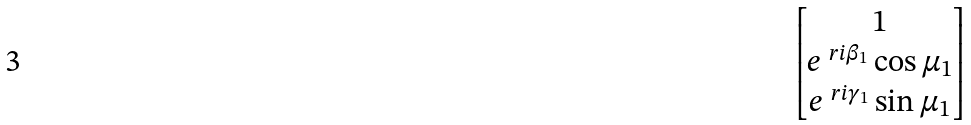Convert formula to latex. <formula><loc_0><loc_0><loc_500><loc_500>\begin{bmatrix} 1 \\ e ^ { \ r i \beta _ { 1 } } \cos \mu _ { 1 } \\ e ^ { \ r i \gamma _ { 1 } } \sin \mu _ { 1 } \end{bmatrix}</formula> 